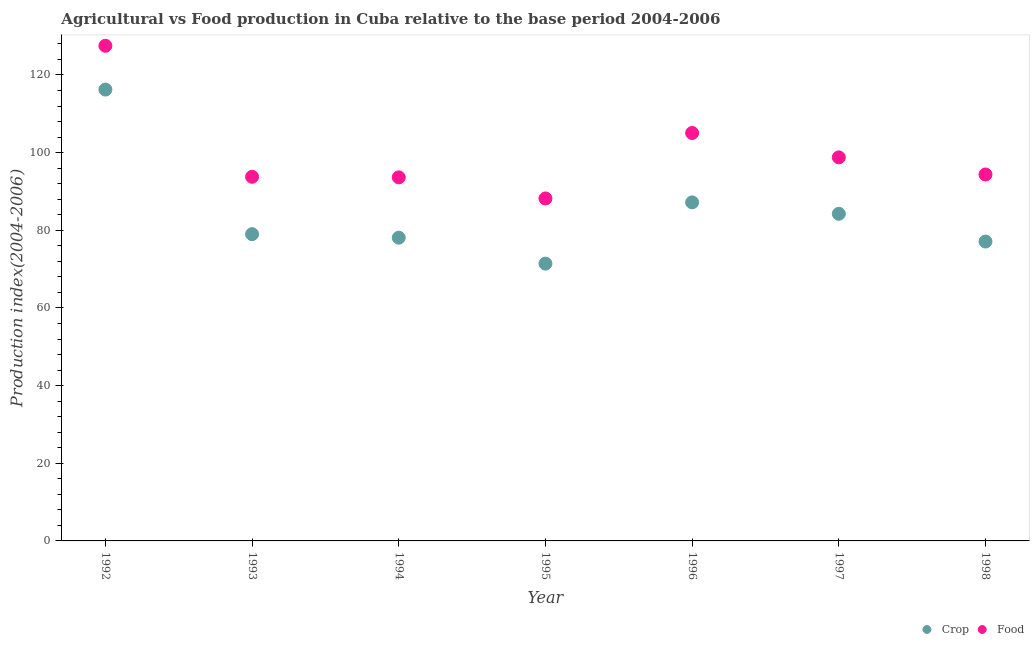How many different coloured dotlines are there?
Offer a terse response. 2. What is the food production index in 1995?
Ensure brevity in your answer.  88.2. Across all years, what is the maximum food production index?
Make the answer very short. 127.52. Across all years, what is the minimum food production index?
Keep it short and to the point. 88.2. What is the total food production index in the graph?
Give a very brief answer. 701.34. What is the difference between the crop production index in 1997 and that in 1998?
Keep it short and to the point. 7.15. What is the difference between the food production index in 1994 and the crop production index in 1992?
Provide a succinct answer. -22.61. What is the average food production index per year?
Ensure brevity in your answer.  100.19. In the year 1992, what is the difference between the food production index and crop production index?
Your response must be concise. 11.28. What is the ratio of the crop production index in 1992 to that in 1993?
Provide a short and direct response. 1.47. Is the crop production index in 1992 less than that in 1997?
Offer a very short reply. No. What is the difference between the highest and the second highest food production index?
Provide a short and direct response. 22.46. What is the difference between the highest and the lowest crop production index?
Give a very brief answer. 44.83. Is the crop production index strictly greater than the food production index over the years?
Give a very brief answer. No. What is the difference between two consecutive major ticks on the Y-axis?
Your answer should be compact. 20. Are the values on the major ticks of Y-axis written in scientific E-notation?
Your answer should be compact. No. Does the graph contain any zero values?
Provide a succinct answer. No. Does the graph contain grids?
Make the answer very short. No. Where does the legend appear in the graph?
Provide a succinct answer. Bottom right. How many legend labels are there?
Offer a very short reply. 2. How are the legend labels stacked?
Ensure brevity in your answer.  Horizontal. What is the title of the graph?
Provide a short and direct response. Agricultural vs Food production in Cuba relative to the base period 2004-2006. Does "Total Population" appear as one of the legend labels in the graph?
Offer a terse response. No. What is the label or title of the X-axis?
Your response must be concise. Year. What is the label or title of the Y-axis?
Offer a very short reply. Production index(2004-2006). What is the Production index(2004-2006) in Crop in 1992?
Your answer should be very brief. 116.24. What is the Production index(2004-2006) of Food in 1992?
Offer a terse response. 127.52. What is the Production index(2004-2006) in Crop in 1993?
Keep it short and to the point. 79. What is the Production index(2004-2006) in Food in 1993?
Your response must be concise. 93.78. What is the Production index(2004-2006) of Crop in 1994?
Ensure brevity in your answer.  78.1. What is the Production index(2004-2006) of Food in 1994?
Make the answer very short. 93.63. What is the Production index(2004-2006) in Crop in 1995?
Your response must be concise. 71.41. What is the Production index(2004-2006) in Food in 1995?
Your answer should be compact. 88.2. What is the Production index(2004-2006) of Crop in 1996?
Your response must be concise. 87.19. What is the Production index(2004-2006) in Food in 1996?
Make the answer very short. 105.06. What is the Production index(2004-2006) in Crop in 1997?
Ensure brevity in your answer.  84.25. What is the Production index(2004-2006) in Food in 1997?
Offer a terse response. 98.78. What is the Production index(2004-2006) of Crop in 1998?
Your response must be concise. 77.1. What is the Production index(2004-2006) in Food in 1998?
Your answer should be very brief. 94.37. Across all years, what is the maximum Production index(2004-2006) in Crop?
Provide a short and direct response. 116.24. Across all years, what is the maximum Production index(2004-2006) in Food?
Give a very brief answer. 127.52. Across all years, what is the minimum Production index(2004-2006) in Crop?
Give a very brief answer. 71.41. Across all years, what is the minimum Production index(2004-2006) in Food?
Offer a terse response. 88.2. What is the total Production index(2004-2006) in Crop in the graph?
Your answer should be very brief. 593.29. What is the total Production index(2004-2006) in Food in the graph?
Your answer should be very brief. 701.34. What is the difference between the Production index(2004-2006) in Crop in 1992 and that in 1993?
Make the answer very short. 37.24. What is the difference between the Production index(2004-2006) of Food in 1992 and that in 1993?
Offer a very short reply. 33.74. What is the difference between the Production index(2004-2006) of Crop in 1992 and that in 1994?
Make the answer very short. 38.14. What is the difference between the Production index(2004-2006) of Food in 1992 and that in 1994?
Ensure brevity in your answer.  33.89. What is the difference between the Production index(2004-2006) of Crop in 1992 and that in 1995?
Offer a very short reply. 44.83. What is the difference between the Production index(2004-2006) of Food in 1992 and that in 1995?
Offer a terse response. 39.32. What is the difference between the Production index(2004-2006) in Crop in 1992 and that in 1996?
Offer a terse response. 29.05. What is the difference between the Production index(2004-2006) in Food in 1992 and that in 1996?
Your response must be concise. 22.46. What is the difference between the Production index(2004-2006) in Crop in 1992 and that in 1997?
Your answer should be compact. 31.99. What is the difference between the Production index(2004-2006) in Food in 1992 and that in 1997?
Provide a short and direct response. 28.74. What is the difference between the Production index(2004-2006) in Crop in 1992 and that in 1998?
Ensure brevity in your answer.  39.14. What is the difference between the Production index(2004-2006) in Food in 1992 and that in 1998?
Your answer should be compact. 33.15. What is the difference between the Production index(2004-2006) in Crop in 1993 and that in 1995?
Your response must be concise. 7.59. What is the difference between the Production index(2004-2006) of Food in 1993 and that in 1995?
Offer a terse response. 5.58. What is the difference between the Production index(2004-2006) of Crop in 1993 and that in 1996?
Make the answer very short. -8.19. What is the difference between the Production index(2004-2006) in Food in 1993 and that in 1996?
Provide a short and direct response. -11.28. What is the difference between the Production index(2004-2006) of Crop in 1993 and that in 1997?
Ensure brevity in your answer.  -5.25. What is the difference between the Production index(2004-2006) of Food in 1993 and that in 1997?
Your answer should be very brief. -5. What is the difference between the Production index(2004-2006) in Crop in 1993 and that in 1998?
Make the answer very short. 1.9. What is the difference between the Production index(2004-2006) of Food in 1993 and that in 1998?
Your answer should be compact. -0.59. What is the difference between the Production index(2004-2006) in Crop in 1994 and that in 1995?
Provide a succinct answer. 6.69. What is the difference between the Production index(2004-2006) of Food in 1994 and that in 1995?
Make the answer very short. 5.43. What is the difference between the Production index(2004-2006) of Crop in 1994 and that in 1996?
Provide a succinct answer. -9.09. What is the difference between the Production index(2004-2006) of Food in 1994 and that in 1996?
Provide a succinct answer. -11.43. What is the difference between the Production index(2004-2006) of Crop in 1994 and that in 1997?
Your answer should be compact. -6.15. What is the difference between the Production index(2004-2006) of Food in 1994 and that in 1997?
Offer a terse response. -5.15. What is the difference between the Production index(2004-2006) in Food in 1994 and that in 1998?
Make the answer very short. -0.74. What is the difference between the Production index(2004-2006) of Crop in 1995 and that in 1996?
Offer a terse response. -15.78. What is the difference between the Production index(2004-2006) of Food in 1995 and that in 1996?
Your response must be concise. -16.86. What is the difference between the Production index(2004-2006) of Crop in 1995 and that in 1997?
Offer a terse response. -12.84. What is the difference between the Production index(2004-2006) of Food in 1995 and that in 1997?
Provide a succinct answer. -10.58. What is the difference between the Production index(2004-2006) in Crop in 1995 and that in 1998?
Your answer should be compact. -5.69. What is the difference between the Production index(2004-2006) in Food in 1995 and that in 1998?
Your response must be concise. -6.17. What is the difference between the Production index(2004-2006) in Crop in 1996 and that in 1997?
Offer a very short reply. 2.94. What is the difference between the Production index(2004-2006) in Food in 1996 and that in 1997?
Your answer should be compact. 6.28. What is the difference between the Production index(2004-2006) of Crop in 1996 and that in 1998?
Make the answer very short. 10.09. What is the difference between the Production index(2004-2006) of Food in 1996 and that in 1998?
Make the answer very short. 10.69. What is the difference between the Production index(2004-2006) of Crop in 1997 and that in 1998?
Make the answer very short. 7.15. What is the difference between the Production index(2004-2006) of Food in 1997 and that in 1998?
Your response must be concise. 4.41. What is the difference between the Production index(2004-2006) of Crop in 1992 and the Production index(2004-2006) of Food in 1993?
Provide a succinct answer. 22.46. What is the difference between the Production index(2004-2006) in Crop in 1992 and the Production index(2004-2006) in Food in 1994?
Your answer should be compact. 22.61. What is the difference between the Production index(2004-2006) in Crop in 1992 and the Production index(2004-2006) in Food in 1995?
Ensure brevity in your answer.  28.04. What is the difference between the Production index(2004-2006) in Crop in 1992 and the Production index(2004-2006) in Food in 1996?
Provide a succinct answer. 11.18. What is the difference between the Production index(2004-2006) of Crop in 1992 and the Production index(2004-2006) of Food in 1997?
Provide a succinct answer. 17.46. What is the difference between the Production index(2004-2006) in Crop in 1992 and the Production index(2004-2006) in Food in 1998?
Your response must be concise. 21.87. What is the difference between the Production index(2004-2006) of Crop in 1993 and the Production index(2004-2006) of Food in 1994?
Ensure brevity in your answer.  -14.63. What is the difference between the Production index(2004-2006) of Crop in 1993 and the Production index(2004-2006) of Food in 1995?
Offer a very short reply. -9.2. What is the difference between the Production index(2004-2006) in Crop in 1993 and the Production index(2004-2006) in Food in 1996?
Make the answer very short. -26.06. What is the difference between the Production index(2004-2006) of Crop in 1993 and the Production index(2004-2006) of Food in 1997?
Offer a very short reply. -19.78. What is the difference between the Production index(2004-2006) of Crop in 1993 and the Production index(2004-2006) of Food in 1998?
Ensure brevity in your answer.  -15.37. What is the difference between the Production index(2004-2006) in Crop in 1994 and the Production index(2004-2006) in Food in 1996?
Provide a short and direct response. -26.96. What is the difference between the Production index(2004-2006) of Crop in 1994 and the Production index(2004-2006) of Food in 1997?
Provide a short and direct response. -20.68. What is the difference between the Production index(2004-2006) in Crop in 1994 and the Production index(2004-2006) in Food in 1998?
Provide a short and direct response. -16.27. What is the difference between the Production index(2004-2006) in Crop in 1995 and the Production index(2004-2006) in Food in 1996?
Offer a very short reply. -33.65. What is the difference between the Production index(2004-2006) in Crop in 1995 and the Production index(2004-2006) in Food in 1997?
Offer a terse response. -27.37. What is the difference between the Production index(2004-2006) of Crop in 1995 and the Production index(2004-2006) of Food in 1998?
Make the answer very short. -22.96. What is the difference between the Production index(2004-2006) of Crop in 1996 and the Production index(2004-2006) of Food in 1997?
Keep it short and to the point. -11.59. What is the difference between the Production index(2004-2006) of Crop in 1996 and the Production index(2004-2006) of Food in 1998?
Your answer should be very brief. -7.18. What is the difference between the Production index(2004-2006) in Crop in 1997 and the Production index(2004-2006) in Food in 1998?
Your response must be concise. -10.12. What is the average Production index(2004-2006) in Crop per year?
Provide a succinct answer. 84.76. What is the average Production index(2004-2006) in Food per year?
Keep it short and to the point. 100.19. In the year 1992, what is the difference between the Production index(2004-2006) in Crop and Production index(2004-2006) in Food?
Make the answer very short. -11.28. In the year 1993, what is the difference between the Production index(2004-2006) in Crop and Production index(2004-2006) in Food?
Your answer should be compact. -14.78. In the year 1994, what is the difference between the Production index(2004-2006) in Crop and Production index(2004-2006) in Food?
Ensure brevity in your answer.  -15.53. In the year 1995, what is the difference between the Production index(2004-2006) of Crop and Production index(2004-2006) of Food?
Your answer should be compact. -16.79. In the year 1996, what is the difference between the Production index(2004-2006) of Crop and Production index(2004-2006) of Food?
Ensure brevity in your answer.  -17.87. In the year 1997, what is the difference between the Production index(2004-2006) of Crop and Production index(2004-2006) of Food?
Your answer should be compact. -14.53. In the year 1998, what is the difference between the Production index(2004-2006) of Crop and Production index(2004-2006) of Food?
Offer a very short reply. -17.27. What is the ratio of the Production index(2004-2006) of Crop in 1992 to that in 1993?
Provide a short and direct response. 1.47. What is the ratio of the Production index(2004-2006) of Food in 1992 to that in 1993?
Offer a very short reply. 1.36. What is the ratio of the Production index(2004-2006) of Crop in 1992 to that in 1994?
Keep it short and to the point. 1.49. What is the ratio of the Production index(2004-2006) in Food in 1992 to that in 1994?
Ensure brevity in your answer.  1.36. What is the ratio of the Production index(2004-2006) of Crop in 1992 to that in 1995?
Your answer should be compact. 1.63. What is the ratio of the Production index(2004-2006) of Food in 1992 to that in 1995?
Ensure brevity in your answer.  1.45. What is the ratio of the Production index(2004-2006) of Crop in 1992 to that in 1996?
Ensure brevity in your answer.  1.33. What is the ratio of the Production index(2004-2006) in Food in 1992 to that in 1996?
Your answer should be compact. 1.21. What is the ratio of the Production index(2004-2006) of Crop in 1992 to that in 1997?
Your answer should be compact. 1.38. What is the ratio of the Production index(2004-2006) of Food in 1992 to that in 1997?
Give a very brief answer. 1.29. What is the ratio of the Production index(2004-2006) in Crop in 1992 to that in 1998?
Keep it short and to the point. 1.51. What is the ratio of the Production index(2004-2006) of Food in 1992 to that in 1998?
Provide a short and direct response. 1.35. What is the ratio of the Production index(2004-2006) in Crop in 1993 to that in 1994?
Ensure brevity in your answer.  1.01. What is the ratio of the Production index(2004-2006) of Food in 1993 to that in 1994?
Ensure brevity in your answer.  1. What is the ratio of the Production index(2004-2006) in Crop in 1993 to that in 1995?
Offer a terse response. 1.11. What is the ratio of the Production index(2004-2006) in Food in 1993 to that in 1995?
Make the answer very short. 1.06. What is the ratio of the Production index(2004-2006) in Crop in 1993 to that in 1996?
Offer a terse response. 0.91. What is the ratio of the Production index(2004-2006) of Food in 1993 to that in 1996?
Provide a succinct answer. 0.89. What is the ratio of the Production index(2004-2006) in Crop in 1993 to that in 1997?
Provide a succinct answer. 0.94. What is the ratio of the Production index(2004-2006) of Food in 1993 to that in 1997?
Your answer should be compact. 0.95. What is the ratio of the Production index(2004-2006) in Crop in 1993 to that in 1998?
Keep it short and to the point. 1.02. What is the ratio of the Production index(2004-2006) in Crop in 1994 to that in 1995?
Ensure brevity in your answer.  1.09. What is the ratio of the Production index(2004-2006) of Food in 1994 to that in 1995?
Offer a very short reply. 1.06. What is the ratio of the Production index(2004-2006) of Crop in 1994 to that in 1996?
Your answer should be compact. 0.9. What is the ratio of the Production index(2004-2006) of Food in 1994 to that in 1996?
Your answer should be very brief. 0.89. What is the ratio of the Production index(2004-2006) in Crop in 1994 to that in 1997?
Your answer should be very brief. 0.93. What is the ratio of the Production index(2004-2006) of Food in 1994 to that in 1997?
Provide a succinct answer. 0.95. What is the ratio of the Production index(2004-2006) of Crop in 1995 to that in 1996?
Your response must be concise. 0.82. What is the ratio of the Production index(2004-2006) of Food in 1995 to that in 1996?
Make the answer very short. 0.84. What is the ratio of the Production index(2004-2006) of Crop in 1995 to that in 1997?
Keep it short and to the point. 0.85. What is the ratio of the Production index(2004-2006) in Food in 1995 to that in 1997?
Offer a very short reply. 0.89. What is the ratio of the Production index(2004-2006) of Crop in 1995 to that in 1998?
Provide a succinct answer. 0.93. What is the ratio of the Production index(2004-2006) of Food in 1995 to that in 1998?
Provide a short and direct response. 0.93. What is the ratio of the Production index(2004-2006) in Crop in 1996 to that in 1997?
Your answer should be compact. 1.03. What is the ratio of the Production index(2004-2006) in Food in 1996 to that in 1997?
Make the answer very short. 1.06. What is the ratio of the Production index(2004-2006) in Crop in 1996 to that in 1998?
Ensure brevity in your answer.  1.13. What is the ratio of the Production index(2004-2006) of Food in 1996 to that in 1998?
Offer a very short reply. 1.11. What is the ratio of the Production index(2004-2006) of Crop in 1997 to that in 1998?
Make the answer very short. 1.09. What is the ratio of the Production index(2004-2006) in Food in 1997 to that in 1998?
Offer a very short reply. 1.05. What is the difference between the highest and the second highest Production index(2004-2006) of Crop?
Provide a short and direct response. 29.05. What is the difference between the highest and the second highest Production index(2004-2006) of Food?
Offer a very short reply. 22.46. What is the difference between the highest and the lowest Production index(2004-2006) of Crop?
Give a very brief answer. 44.83. What is the difference between the highest and the lowest Production index(2004-2006) of Food?
Your response must be concise. 39.32. 